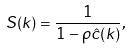Convert formula to latex. <formula><loc_0><loc_0><loc_500><loc_500>S ( k ) = \frac { 1 } { 1 - \rho \hat { c } ( k ) } ,</formula> 